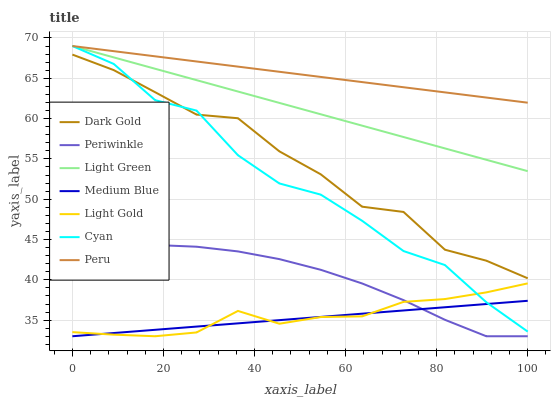Does Dark Gold have the minimum area under the curve?
Answer yes or no. No. Does Dark Gold have the maximum area under the curve?
Answer yes or no. No. Is Dark Gold the smoothest?
Answer yes or no. No. Is Dark Gold the roughest?
Answer yes or no. No. Does Dark Gold have the lowest value?
Answer yes or no. No. Does Dark Gold have the highest value?
Answer yes or no. No. Is Light Gold less than Peru?
Answer yes or no. Yes. Is Peru greater than Dark Gold?
Answer yes or no. Yes. Does Light Gold intersect Peru?
Answer yes or no. No. 